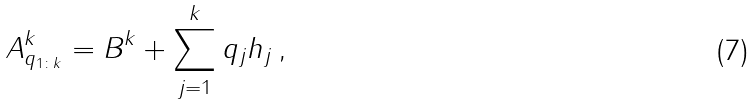Convert formula to latex. <formula><loc_0><loc_0><loc_500><loc_500>A ^ { k } _ { q _ { 1 \colon k } } = B ^ { k } + \sum _ { j = 1 } ^ { k } q _ { j } h _ { j } \, ,</formula> 